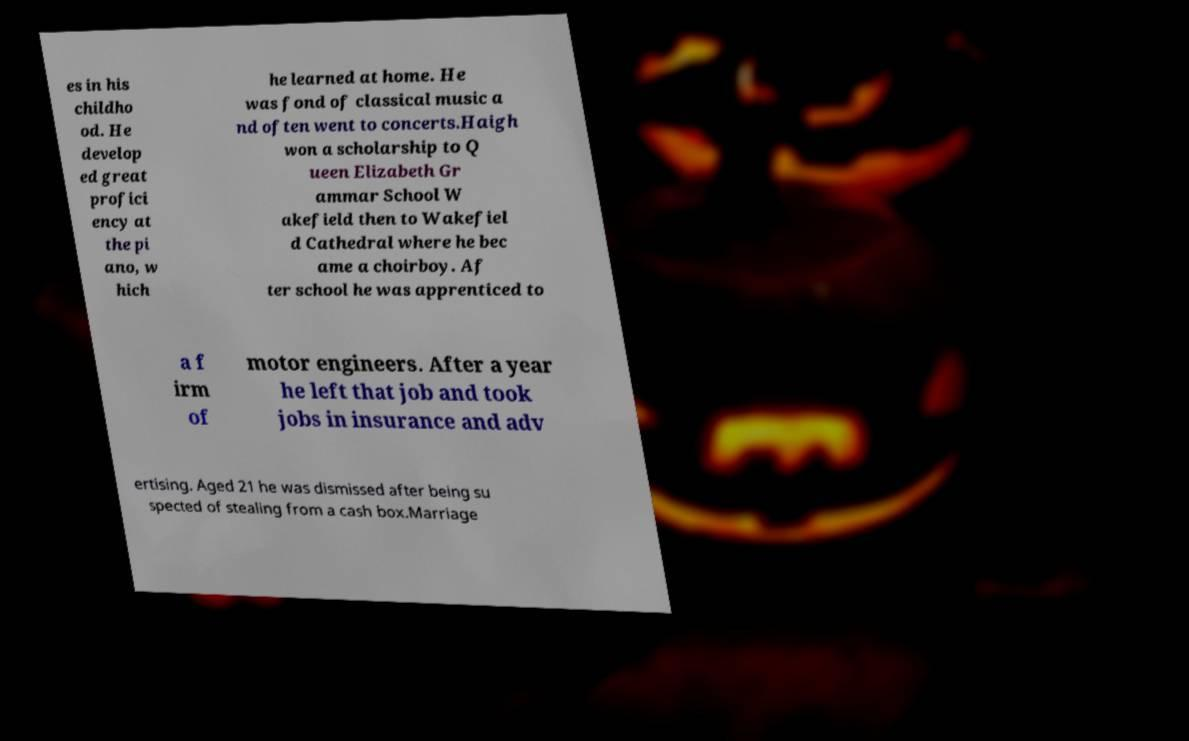Can you accurately transcribe the text from the provided image for me? es in his childho od. He develop ed great profici ency at the pi ano, w hich he learned at home. He was fond of classical music a nd often went to concerts.Haigh won a scholarship to Q ueen Elizabeth Gr ammar School W akefield then to Wakefiel d Cathedral where he bec ame a choirboy. Af ter school he was apprenticed to a f irm of motor engineers. After a year he left that job and took jobs in insurance and adv ertising. Aged 21 he was dismissed after being su spected of stealing from a cash box.Marriage 